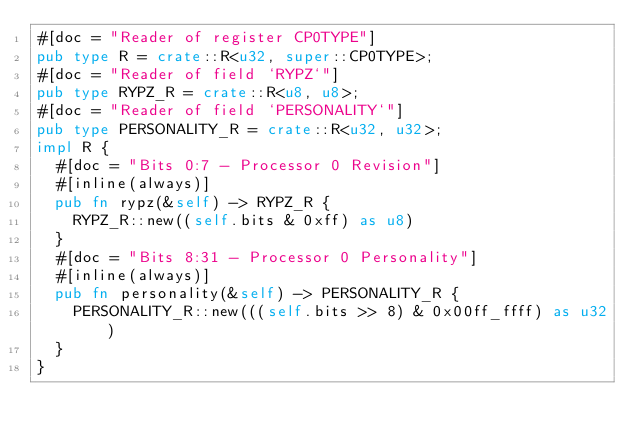<code> <loc_0><loc_0><loc_500><loc_500><_Rust_>#[doc = "Reader of register CP0TYPE"]
pub type R = crate::R<u32, super::CP0TYPE>;
#[doc = "Reader of field `RYPZ`"]
pub type RYPZ_R = crate::R<u8, u8>;
#[doc = "Reader of field `PERSONALITY`"]
pub type PERSONALITY_R = crate::R<u32, u32>;
impl R {
  #[doc = "Bits 0:7 - Processor 0 Revision"]
  #[inline(always)]
  pub fn rypz(&self) -> RYPZ_R {
    RYPZ_R::new((self.bits & 0xff) as u8)
  }
  #[doc = "Bits 8:31 - Processor 0 Personality"]
  #[inline(always)]
  pub fn personality(&self) -> PERSONALITY_R {
    PERSONALITY_R::new(((self.bits >> 8) & 0x00ff_ffff) as u32)
  }
}
</code> 